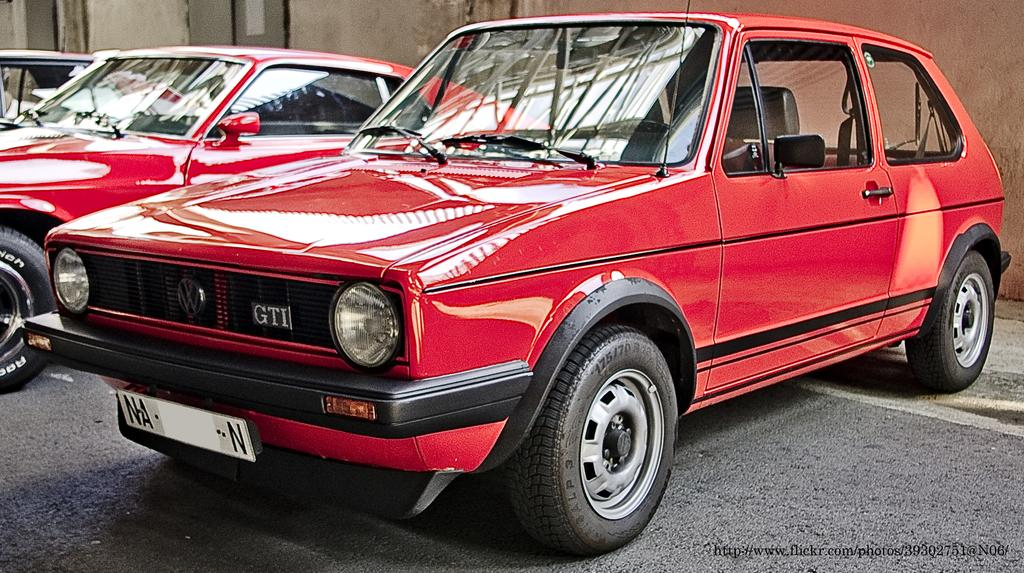<image>
Write a terse but informative summary of the picture. A classic red VW GTI golf is parked next to other classic cars. 